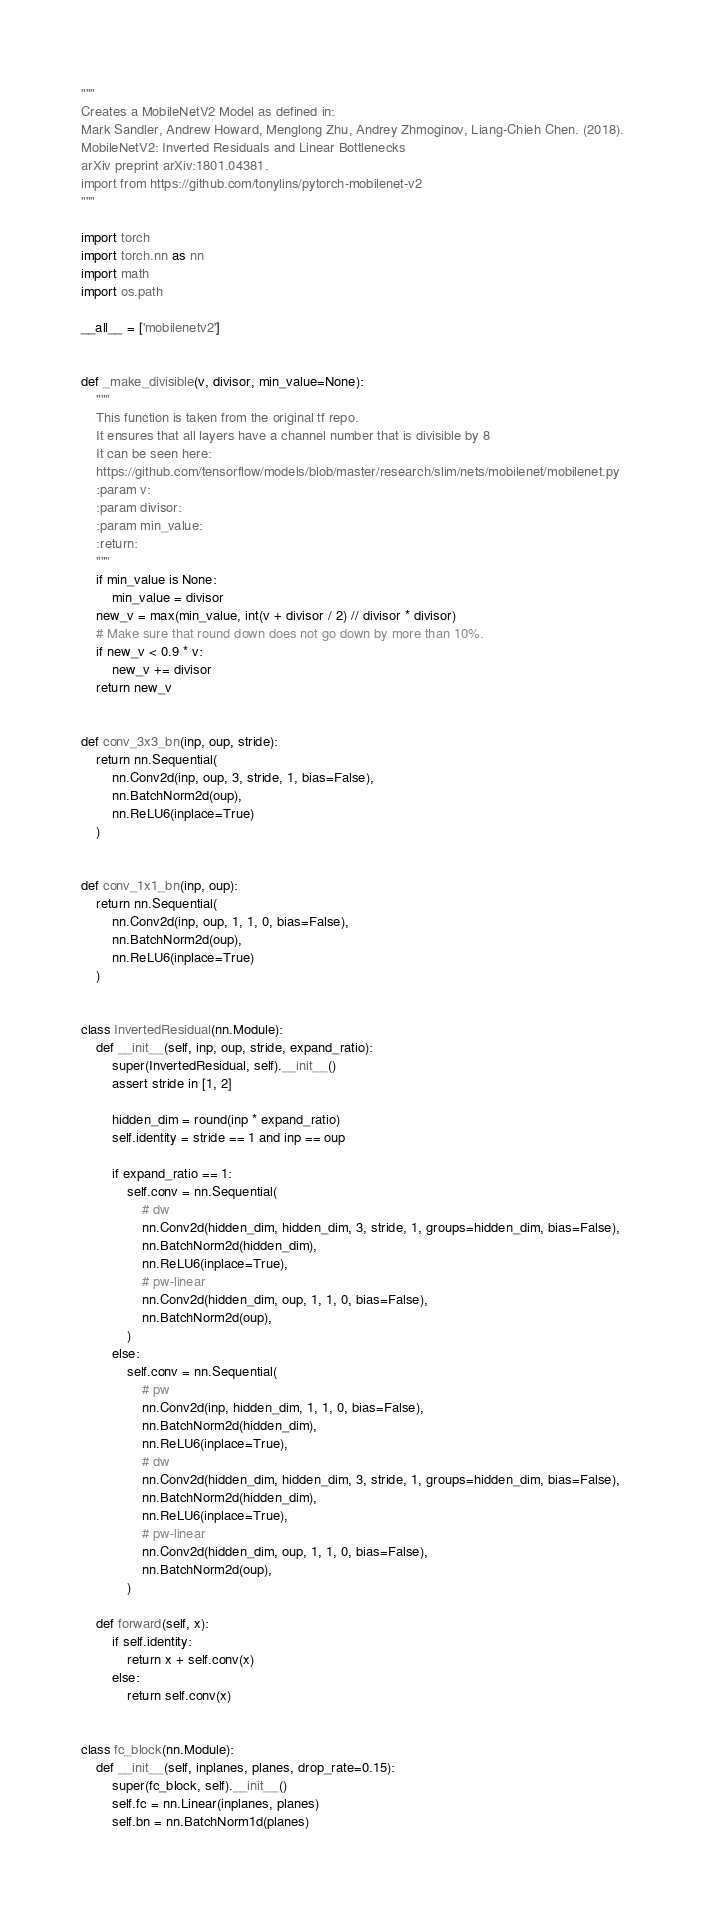<code> <loc_0><loc_0><loc_500><loc_500><_Python_>"""
Creates a MobileNetV2 Model as defined in:
Mark Sandler, Andrew Howard, Menglong Zhu, Andrey Zhmoginov, Liang-Chieh Chen. (2018). 
MobileNetV2: Inverted Residuals and Linear Bottlenecks
arXiv preprint arXiv:1801.04381.
import from https://github.com/tonylins/pytorch-mobilenet-v2
"""

import torch
import torch.nn as nn
import math
import os.path

__all__ = ['mobilenetv2']


def _make_divisible(v, divisor, min_value=None):
    """
    This function is taken from the original tf repo.
    It ensures that all layers have a channel number that is divisible by 8
    It can be seen here:
    https://github.com/tensorflow/models/blob/master/research/slim/nets/mobilenet/mobilenet.py
    :param v:
    :param divisor:
    :param min_value:
    :return:
    """
    if min_value is None:
        min_value = divisor
    new_v = max(min_value, int(v + divisor / 2) // divisor * divisor)
    # Make sure that round down does not go down by more than 10%.
    if new_v < 0.9 * v:
        new_v += divisor
    return new_v


def conv_3x3_bn(inp, oup, stride):
    return nn.Sequential(
        nn.Conv2d(inp, oup, 3, stride, 1, bias=False),
        nn.BatchNorm2d(oup),
        nn.ReLU6(inplace=True)
    )


def conv_1x1_bn(inp, oup):
    return nn.Sequential(
        nn.Conv2d(inp, oup, 1, 1, 0, bias=False),
        nn.BatchNorm2d(oup),
        nn.ReLU6(inplace=True)
    )


class InvertedResidual(nn.Module):
    def __init__(self, inp, oup, stride, expand_ratio):
        super(InvertedResidual, self).__init__()
        assert stride in [1, 2]

        hidden_dim = round(inp * expand_ratio)
        self.identity = stride == 1 and inp == oup

        if expand_ratio == 1:
            self.conv = nn.Sequential(
                # dw
                nn.Conv2d(hidden_dim, hidden_dim, 3, stride, 1, groups=hidden_dim, bias=False),
                nn.BatchNorm2d(hidden_dim),
                nn.ReLU6(inplace=True),
                # pw-linear
                nn.Conv2d(hidden_dim, oup, 1, 1, 0, bias=False),
                nn.BatchNorm2d(oup),
            )
        else:
            self.conv = nn.Sequential(
                # pw
                nn.Conv2d(inp, hidden_dim, 1, 1, 0, bias=False),
                nn.BatchNorm2d(hidden_dim),
                nn.ReLU6(inplace=True),
                # dw
                nn.Conv2d(hidden_dim, hidden_dim, 3, stride, 1, groups=hidden_dim, bias=False),
                nn.BatchNorm2d(hidden_dim),
                nn.ReLU6(inplace=True),
                # pw-linear
                nn.Conv2d(hidden_dim, oup, 1, 1, 0, bias=False),
                nn.BatchNorm2d(oup),
            )

    def forward(self, x):
        if self.identity:
            return x + self.conv(x)
        else:
            return self.conv(x)


class fc_block(nn.Module):
    def __init__(self, inplanes, planes, drop_rate=0.15):
        super(fc_block, self).__init__()
        self.fc = nn.Linear(inplanes, planes)
        self.bn = nn.BatchNorm1d(planes)</code> 